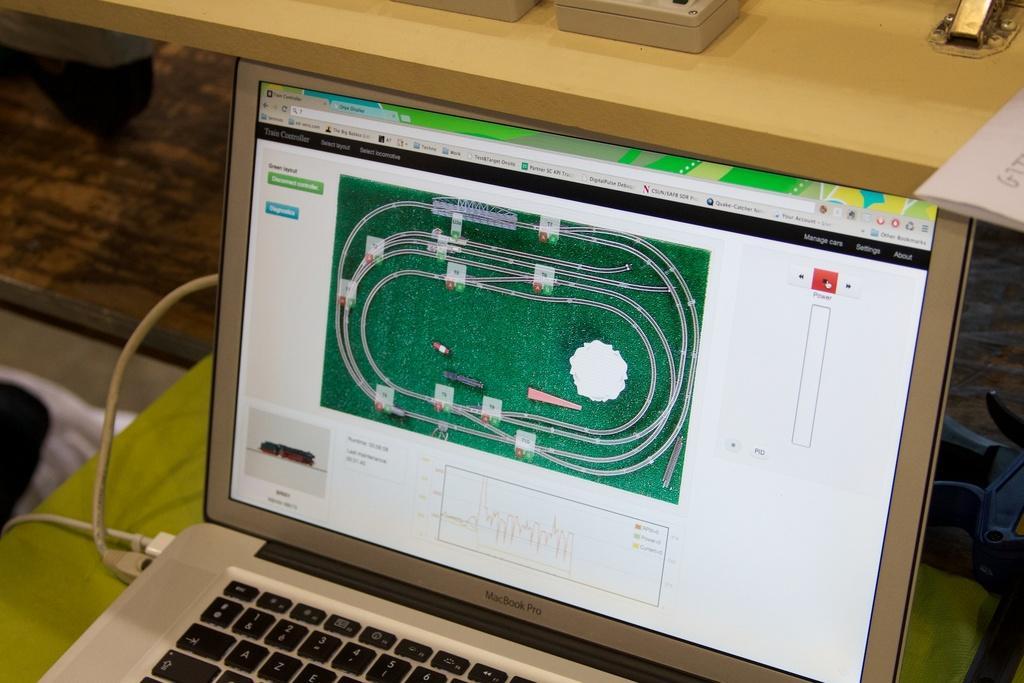Could you give a brief overview of what you see in this image? In this image, we can see some cables connected to a laptop. In the background, there is a table. 